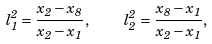Convert formula to latex. <formula><loc_0><loc_0><loc_500><loc_500>l _ { 1 } ^ { 2 } = \frac { x _ { 2 } - x _ { 8 } } { x _ { 2 } - x _ { 1 } } , \quad l _ { 2 } ^ { 2 } = \frac { x _ { 8 } - x _ { 1 } } { x _ { 2 } - x _ { 1 } } ,</formula> 